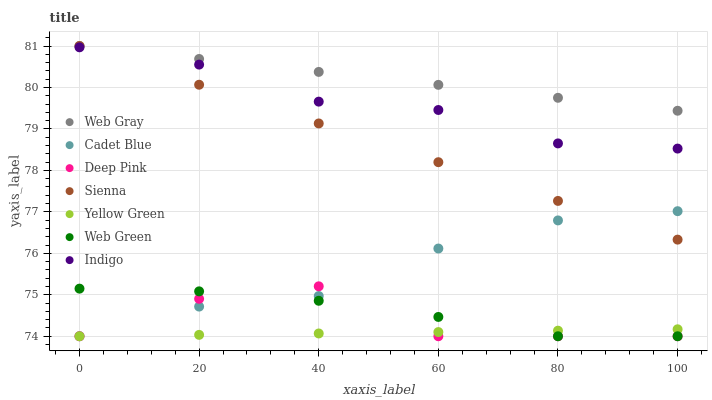Does Yellow Green have the minimum area under the curve?
Answer yes or no. Yes. Does Web Gray have the maximum area under the curve?
Answer yes or no. Yes. Does Indigo have the minimum area under the curve?
Answer yes or no. No. Does Indigo have the maximum area under the curve?
Answer yes or no. No. Is Web Gray the smoothest?
Answer yes or no. Yes. Is Deep Pink the roughest?
Answer yes or no. Yes. Is Indigo the smoothest?
Answer yes or no. No. Is Indigo the roughest?
Answer yes or no. No. Does Cadet Blue have the lowest value?
Answer yes or no. Yes. Does Indigo have the lowest value?
Answer yes or no. No. Does Web Gray have the highest value?
Answer yes or no. Yes. Does Indigo have the highest value?
Answer yes or no. No. Is Indigo less than Web Gray?
Answer yes or no. Yes. Is Sienna greater than Web Green?
Answer yes or no. Yes. Does Cadet Blue intersect Web Green?
Answer yes or no. Yes. Is Cadet Blue less than Web Green?
Answer yes or no. No. Is Cadet Blue greater than Web Green?
Answer yes or no. No. Does Indigo intersect Web Gray?
Answer yes or no. No. 